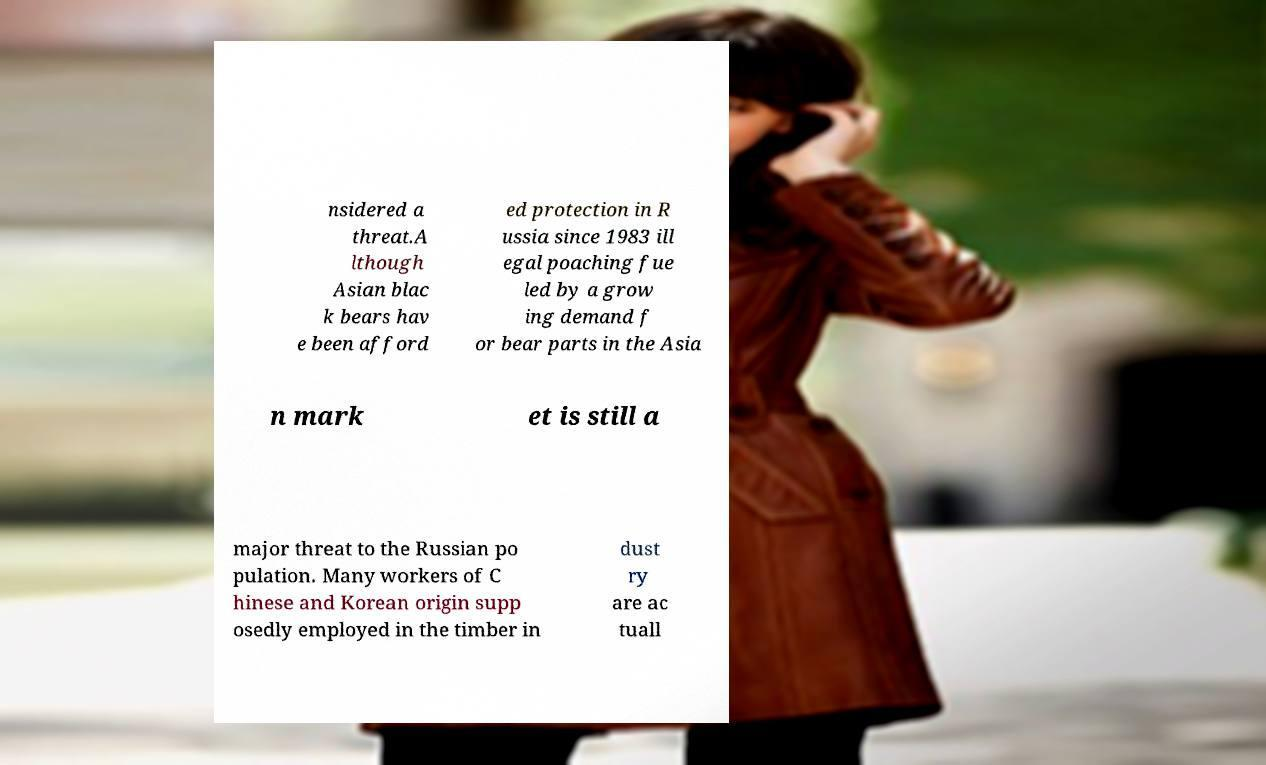Could you assist in decoding the text presented in this image and type it out clearly? nsidered a threat.A lthough Asian blac k bears hav e been afford ed protection in R ussia since 1983 ill egal poaching fue led by a grow ing demand f or bear parts in the Asia n mark et is still a major threat to the Russian po pulation. Many workers of C hinese and Korean origin supp osedly employed in the timber in dust ry are ac tuall 